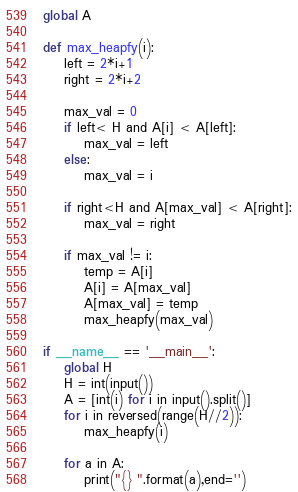<code> <loc_0><loc_0><loc_500><loc_500><_Python_>global A

def max_heapfy(i):
    left = 2*i+1
    right = 2*i+2

    max_val = 0
    if left< H and A[i] < A[left]:
        max_val = left
    else:
        max_val = i

    if right<H and A[max_val] < A[right]:
        max_val = right

    if max_val != i:
        temp = A[i]
        A[i] = A[max_val]
        A[max_val] = temp
        max_heapfy(max_val)

if __name__ == '__main__':
    global H
    H = int(input())
    A = [int(i) for i in input().split()]
    for i in reversed(range(H//2)):
        max_heapfy(i)

    for a in A:
        print("{} ".format(a),end='')</code> 